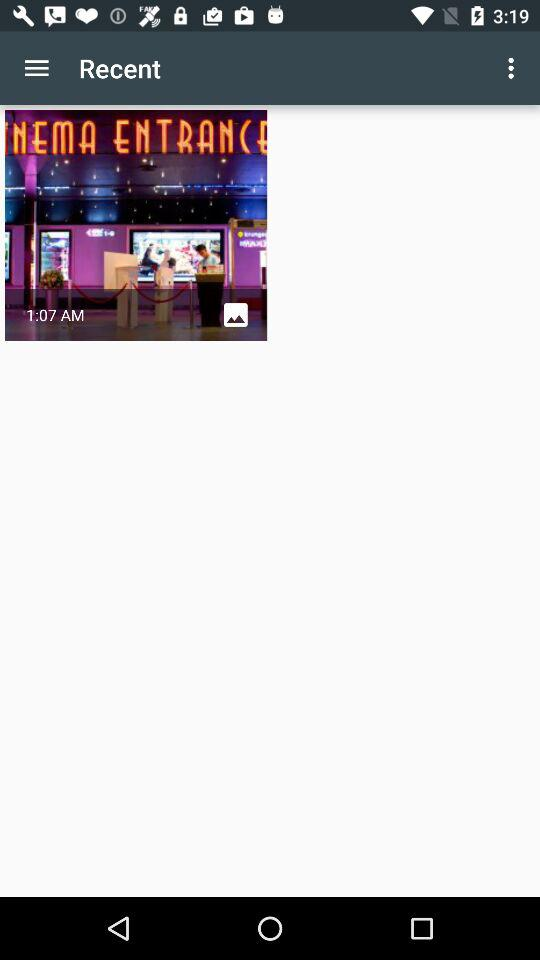What is the time? The time is 1:07 AM. 